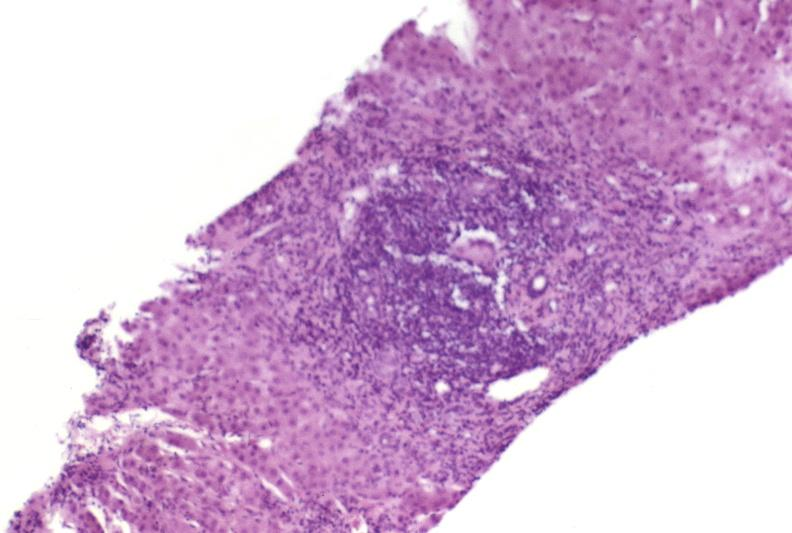s cysticercosis present?
Answer the question using a single word or phrase. No 